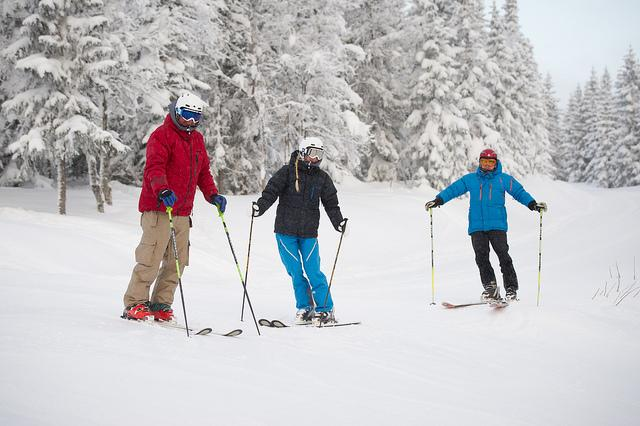A snowblade is made of what? fiberglass 